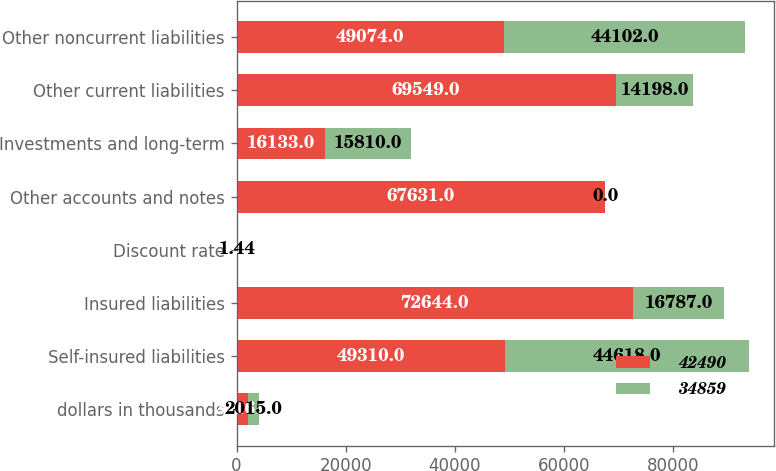Convert chart. <chart><loc_0><loc_0><loc_500><loc_500><stacked_bar_chart><ecel><fcel>dollars in thousands<fcel>Self-insured liabilities<fcel>Insured liabilities<fcel>Discount rate<fcel>Other accounts and notes<fcel>Investments and long-term<fcel>Other current liabilities<fcel>Other noncurrent liabilities<nl><fcel>42490<fcel>2016<fcel>49310<fcel>72644<fcel>1.4<fcel>67631<fcel>16133<fcel>69549<fcel>49074<nl><fcel>34859<fcel>2015<fcel>44618<fcel>16787<fcel>1.44<fcel>0<fcel>15810<fcel>14198<fcel>44102<nl></chart> 